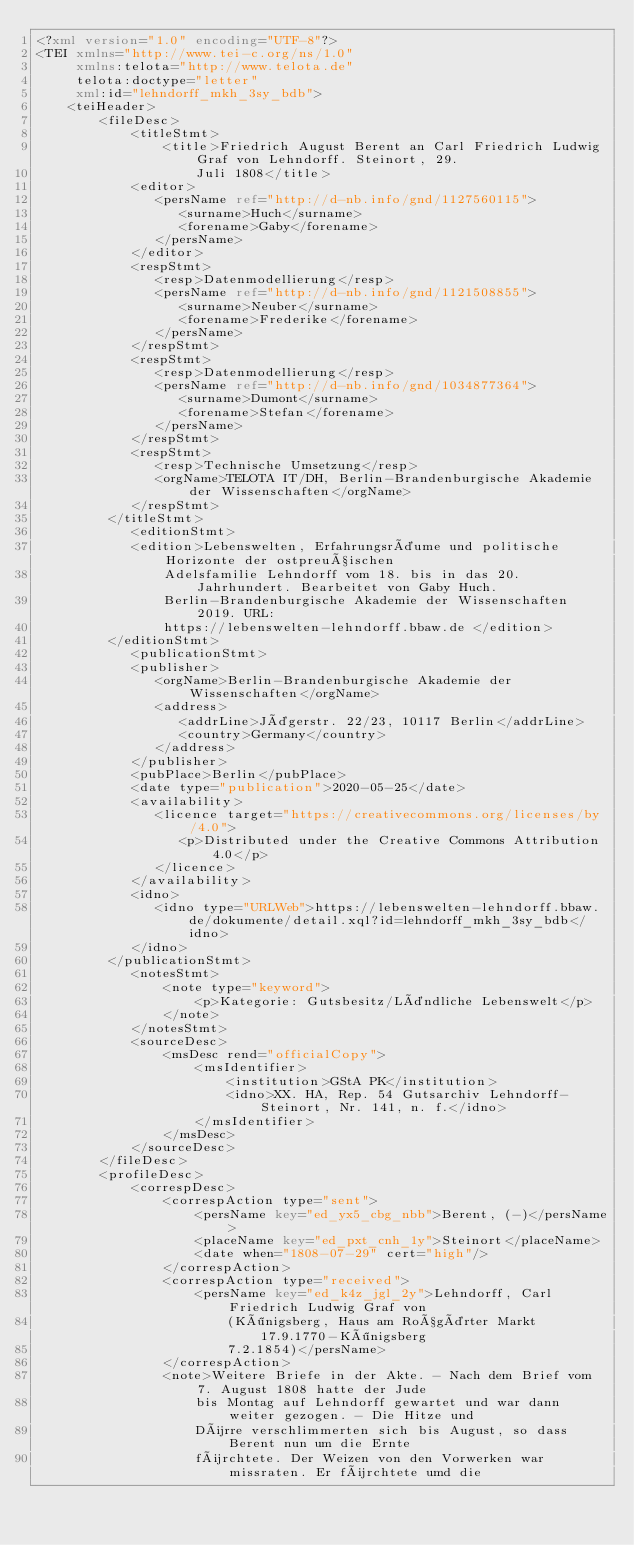Convert code to text. <code><loc_0><loc_0><loc_500><loc_500><_XML_><?xml version="1.0" encoding="UTF-8"?>
<TEI xmlns="http://www.tei-c.org/ns/1.0"
     xmlns:telota="http://www.telota.de"
     telota:doctype="letter"
     xml:id="lehndorff_mkh_3sy_bdb">
    <teiHeader>
        <fileDesc>
            <titleStmt>
                <title>Friedrich August Berent an Carl Friedrich Ludwig Graf von Lehndorff. Steinort, 29.
                    Juli 1808</title>
            <editor>
               <persName ref="http://d-nb.info/gnd/1127560115">
                  <surname>Huch</surname>
                  <forename>Gaby</forename>
               </persName>
            </editor>
            <respStmt>
               <resp>Datenmodellierung</resp>
               <persName ref="http://d-nb.info/gnd/1121508855">
                  <surname>Neuber</surname>
                  <forename>Frederike</forename>
               </persName>
            </respStmt>
            <respStmt>
               <resp>Datenmodellierung</resp>
               <persName ref="http://d-nb.info/gnd/1034877364">
                  <surname>Dumont</surname>
                  <forename>Stefan</forename>
               </persName>
            </respStmt>
            <respStmt>
               <resp>Technische Umsetzung</resp>
               <orgName>TELOTA IT/DH, Berlin-Brandenburgische Akademie der Wissenschaften</orgName>
            </respStmt>
         </titleStmt>
            <editionStmt>
            <edition>Lebenswelten, Erfahrungsräume und politische Horizonte der ostpreußischen
                Adelsfamilie Lehndorff vom 18. bis in das 20. Jahrhundert. Bearbeitet von Gaby Huch.
                Berlin-Brandenburgische Akademie der Wissenschaften 2019. URL:
                https://lebenswelten-lehndorff.bbaw.de </edition>
         </editionStmt>
            <publicationStmt>
            <publisher>
               <orgName>Berlin-Brandenburgische Akademie der Wissenschaften</orgName>
               <address>
                  <addrLine>Jägerstr. 22/23, 10117 Berlin</addrLine>
                  <country>Germany</country>
               </address>
            </publisher>
            <pubPlace>Berlin</pubPlace>
            <date type="publication">2020-05-25</date>
            <availability>
               <licence target="https://creativecommons.org/licenses/by/4.0">
                  <p>Distributed under the Creative Commons Attribution 4.0</p>
               </licence>
            </availability>
            <idno>
               <idno type="URLWeb">https://lebenswelten-lehndorff.bbaw.de/dokumente/detail.xql?id=lehndorff_mkh_3sy_bdb</idno>
            </idno>
         </publicationStmt>
            <notesStmt>
                <note type="keyword">
                    <p>Kategorie: Gutsbesitz/Ländliche Lebenswelt</p>
                </note>
            </notesStmt>
            <sourceDesc>
                <msDesc rend="officialCopy">
                    <msIdentifier>
                        <institution>GStA PK</institution>
                        <idno>XX. HA, Rep. 54 Gutsarchiv Lehndorff-Steinort, Nr. 141, n. f.</idno>
                    </msIdentifier>
                </msDesc>
            </sourceDesc>
        </fileDesc>
        <profileDesc>
            <correspDesc>
                <correspAction type="sent">
                    <persName key="ed_yx5_cbg_nbb">Berent, (-)</persName>
                    <placeName key="ed_pxt_cnh_1y">Steinort</placeName>
                    <date when="1808-07-29" cert="high"/>
                </correspAction>
                <correspAction type="received">
                    <persName key="ed_k4z_jgl_2y">Lehndorff, Carl Friedrich Ludwig Graf von
                        (Königsberg, Haus am Roßgärter Markt 17.9.1770-Königsberg
                        7.2.1854)</persName>
                </correspAction>
                <note>Weitere Briefe in der Akte. - Nach dem Brief vom 7. August 1808 hatte der Jude
                    bis Montag auf Lehndorff gewartet und war dann weiter gezogen. - Die Hitze und
                    Dürre verschlimmerten sich bis August, so dass Berent nun um die Ernte
                    fürchtete. Der Weizen von den Vorwerken war missraten. Er fürchtete umd die</code> 